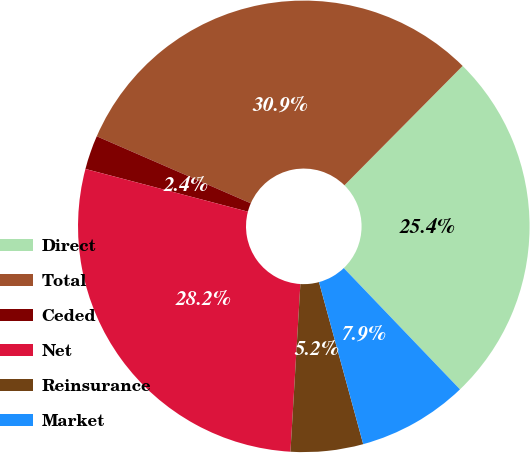Convert chart to OTSL. <chart><loc_0><loc_0><loc_500><loc_500><pie_chart><fcel>Direct<fcel>Total<fcel>Ceded<fcel>Net<fcel>Reinsurance<fcel>Market<nl><fcel>25.42%<fcel>30.89%<fcel>2.44%<fcel>28.15%<fcel>5.18%<fcel>7.92%<nl></chart> 